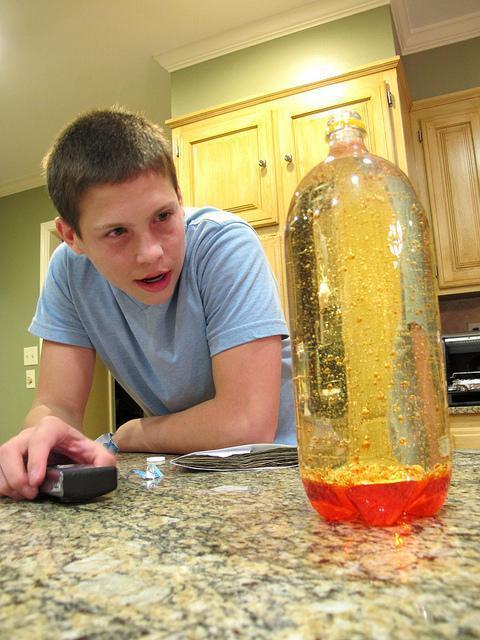What has the boy made using the bottle?
Answer the question by selecting the correct answer among the 4 following choices and explain your choice with a short sentence. The answer should be formatted with the following format: `Answer: choice
Rationale: rationale.`
Options: Bottle rocket, grape jelly, lava lamp, hand sanitizer. Answer: lava lamp.
Rationale: It looks like a volcano exploding. 